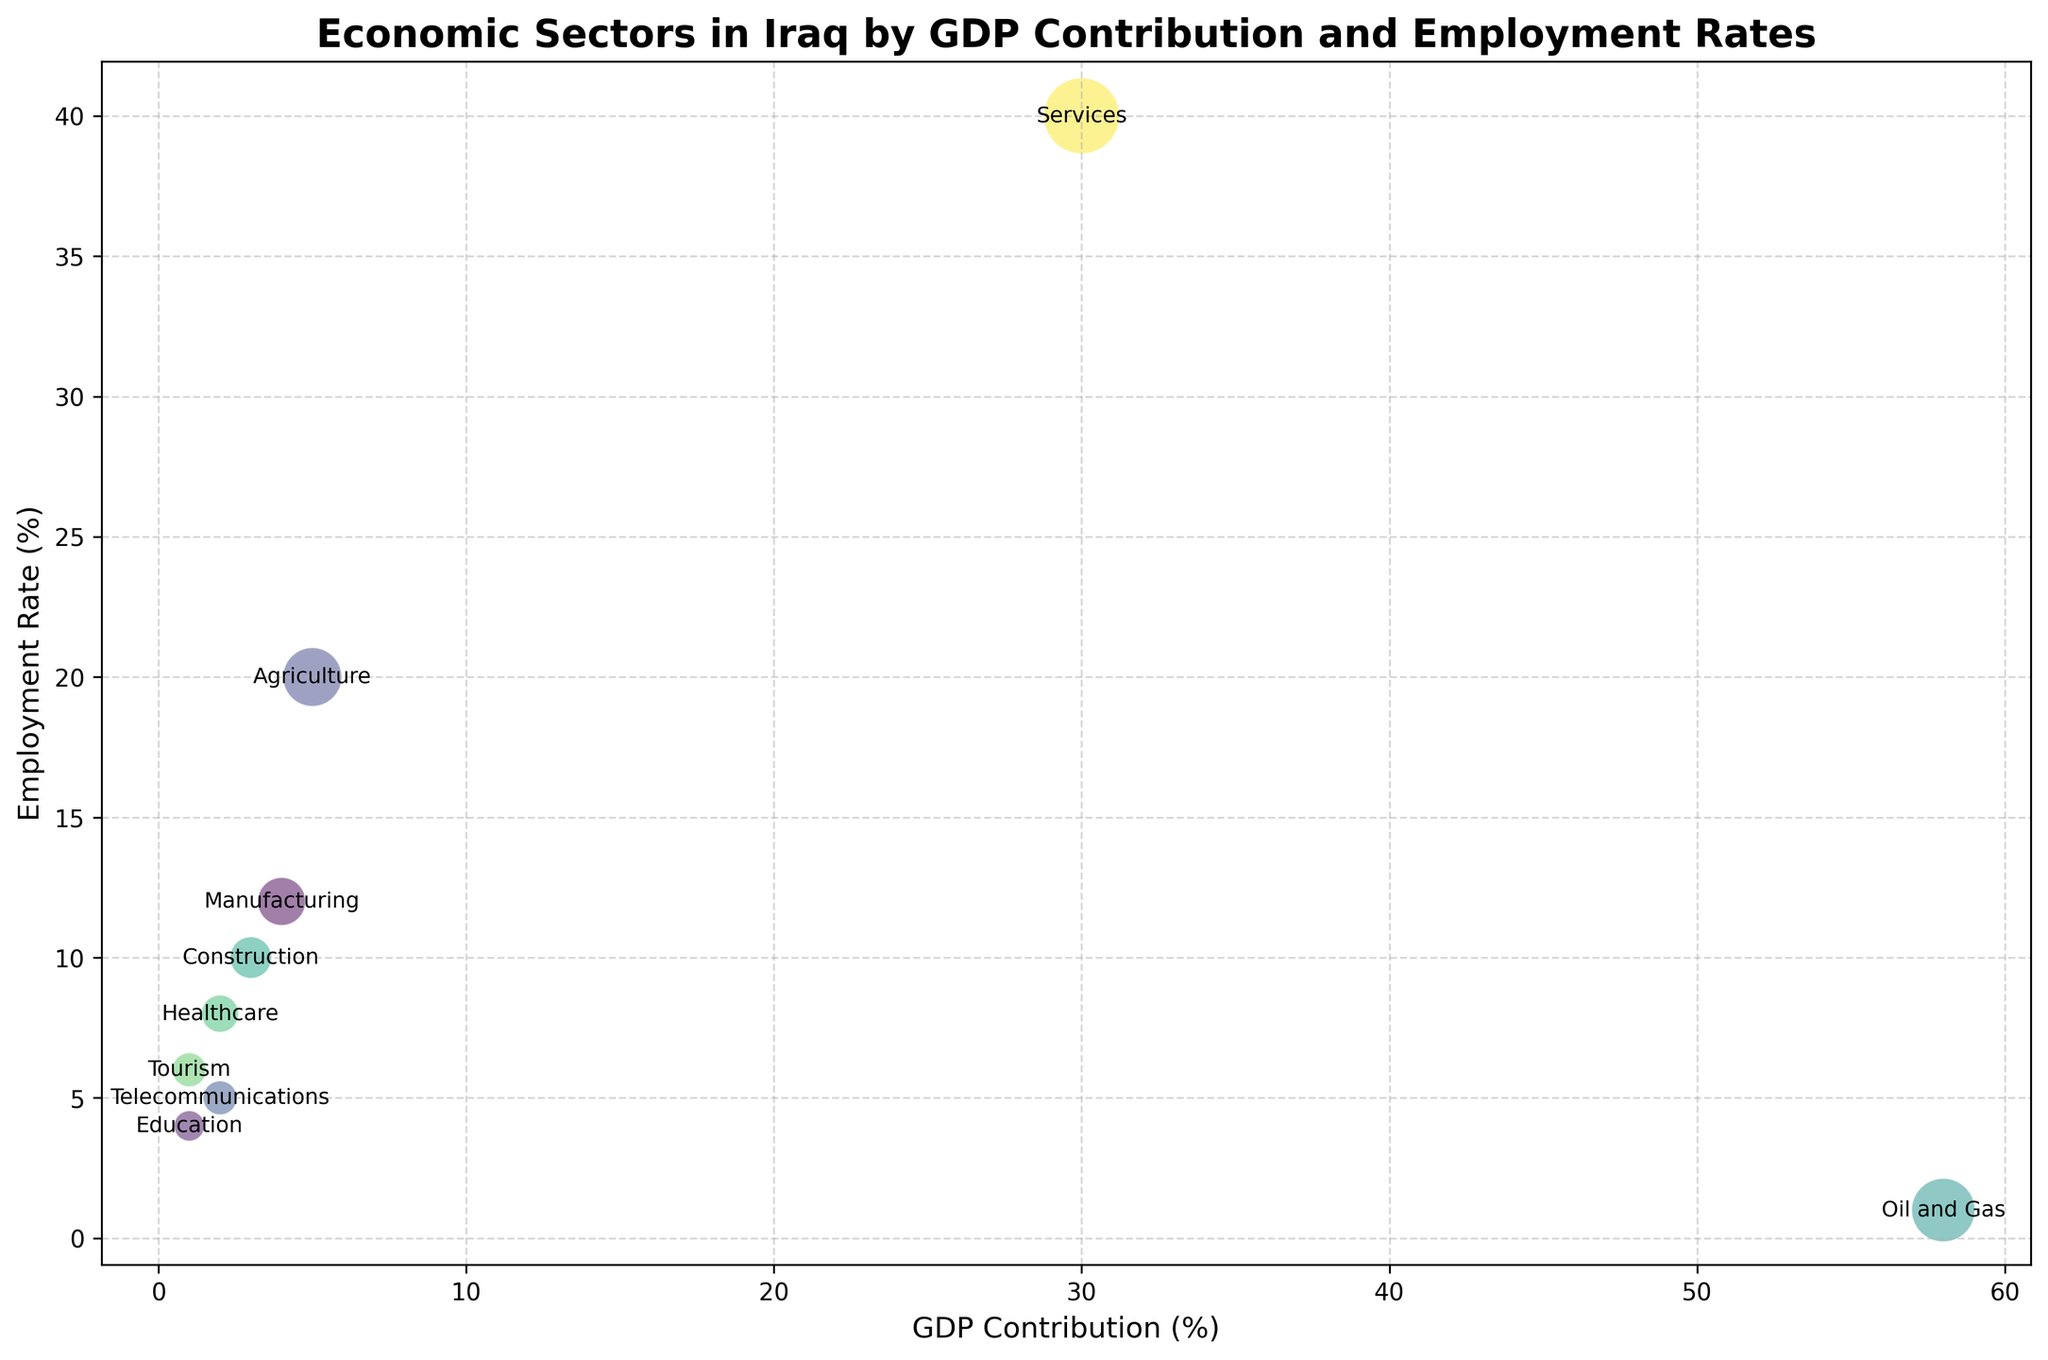What's the economic sector with the highest GDP contribution? The figure shows the GDP contribution of various sectors. The 'Oil and Gas' sector has the highest GDP contribution, as indicated by its position farthest along the GDP Contribution (%) axis and the size of its bubble.
Answer: Oil and Gas Which sector has the highest employment rate? The employment rate is shown on the vertical axis. The 'Services' sector, which has the highest positioning on this axis, represents the highest employment rate.
Answer: Services What is the combined GDP contribution of the 'Agriculture' and 'Manufacturing' sectors? The GDP contribution for 'Agriculture' is 5% and for 'Manufacturing' is 4%. Adding these values gives the combined GDP contribution: 5% + 4%
Answer: 9% How does the employment rate of 'Telecommunications' compare to 'Healthcare'? 'Telecommunications' has an employment rate of 5%, while 'Healthcare' has an employment rate of 8%. Healthcare has a higher employment rate than Telecommunications.
Answer: Healthcare has a higher employment rate What sector contributes the least to GDP? The sector with the smallest bubble and the lowest position along the GDP Contribution (%) axis is 'Education,' indicating the least GDP contribution.
Answer: Education Which sector shows a low GDP contribution but a relatively high employment rate? The sector with a low position on the GDP Contribution axis but a high position on the Employment Rate axis is 'Agriculture.'
Answer: Agriculture If you compare bubble sizes, which sector contributes more to GDP, 'Tourism' or 'Education'? The size of the bubbles represents GDP contribution. 'Tourism' has a larger bubble size than 'Education,' indicating it contributes more to GDP.
Answer: Tourism What percentage of employment do the sectors with 1% GDP contribution add up to? Sectors with 1% GDP contribution are 'Education' and 'Tourism.' Their employment rates are 4% and 6%, respectively. Summing these gives: 4% + 6%
Answer: 10% Does the 'Oil and Gas' sector have a higher employment rate compared to 'Construction'? The 'Oil and Gas' sector's employment rate is 1%, while 'Construction' has an employment rate of 10%. Thus, 'Oil and Gas' has a lower employment rate.
Answer: No What sector has a higher GDP Contribution, 'Healthcare' or 'Telecommunications,' and by how much? 'Healthcare' has a GDP contribution of 2%, and 'Telecommunications' also has a GDP contribution of 2%. The difference is zero.
Answer: They are equal 